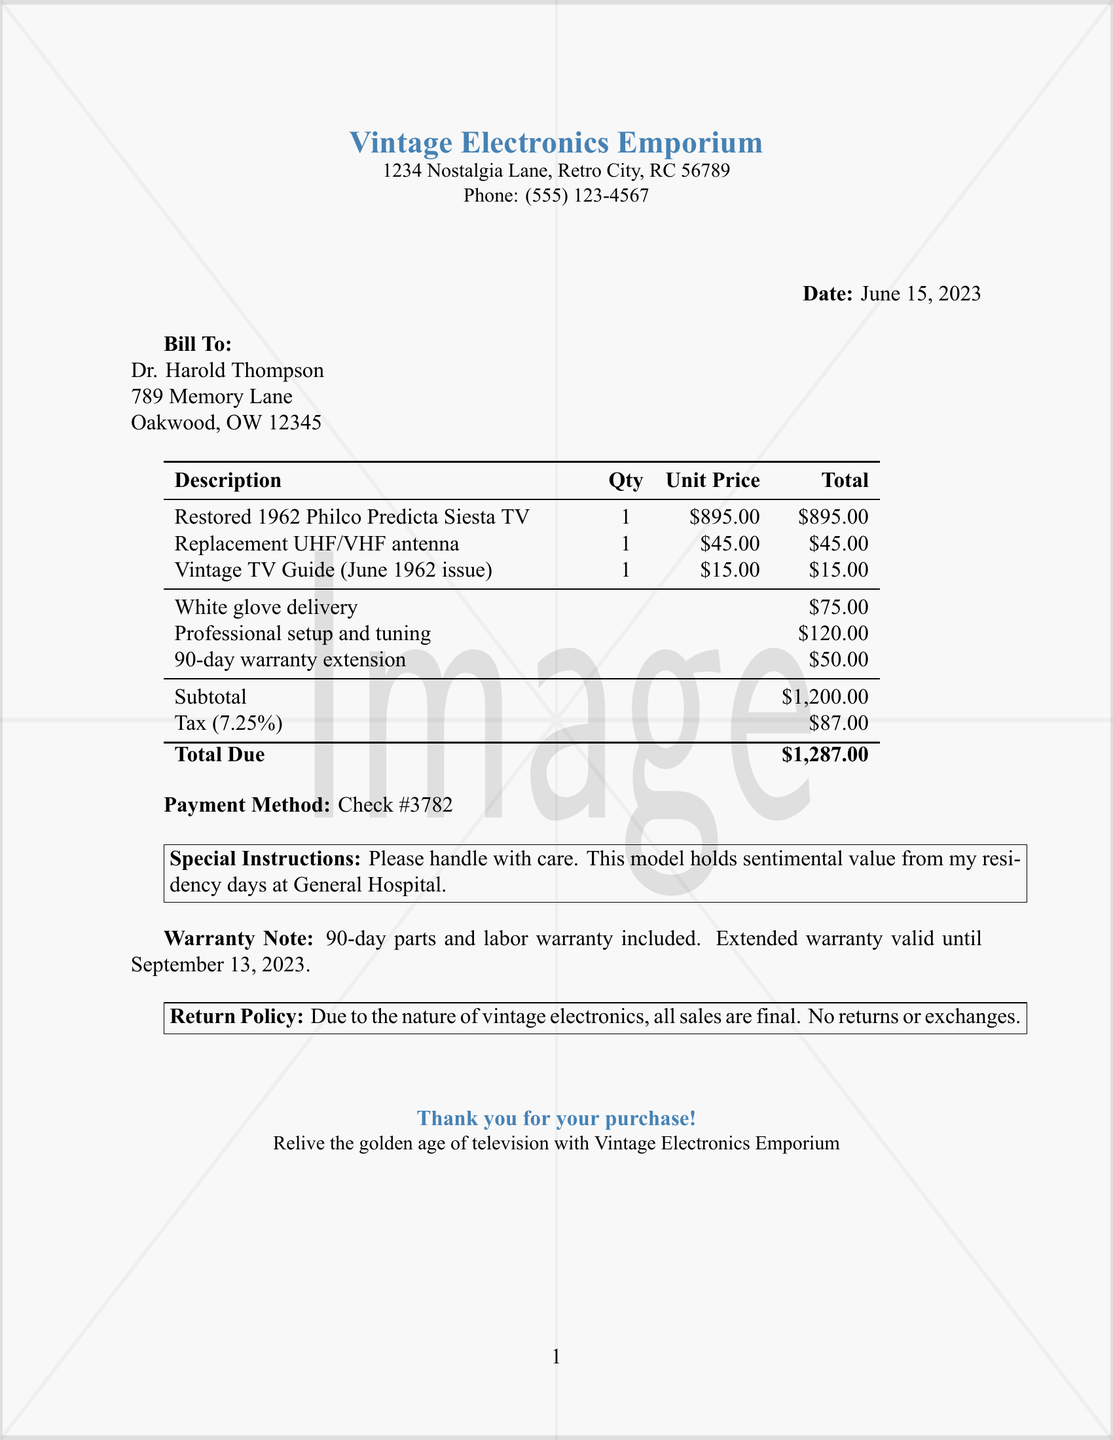What is the name of the store? The store's name is mentioned at the top of the document.
Answer: Vintage Electronics Emporium What is the address of the store? The store's address is located right below the store name.
Answer: 1234 Nostalgia Lane, Retro City, RC 56789 What item was purchased? The first item in the list of purchased items is described.
Answer: Restored 1962 Philco Predicta Siesta TV What is the total due amount? The total due amount is stated at the bottom of the receipt.
Answer: $1,287.00 What is the warranty duration? The warranty note indicates how long the warranty lasts.
Answer: 90-day How much was charged for delivery? The charge for delivery can be found in the services section of the document.
Answer: $75.00 What payment method was used? The payment method is clearly mentioned in the document.
Answer: Check #3782 What are the return policy details? The return policy is stated at the bottom of the document.
Answer: All sales are final. No returns or exchanges Why is there a special instruction noted? The special instruction relates to the sentimental value of the purchased item.
Answer: Please handle with care 